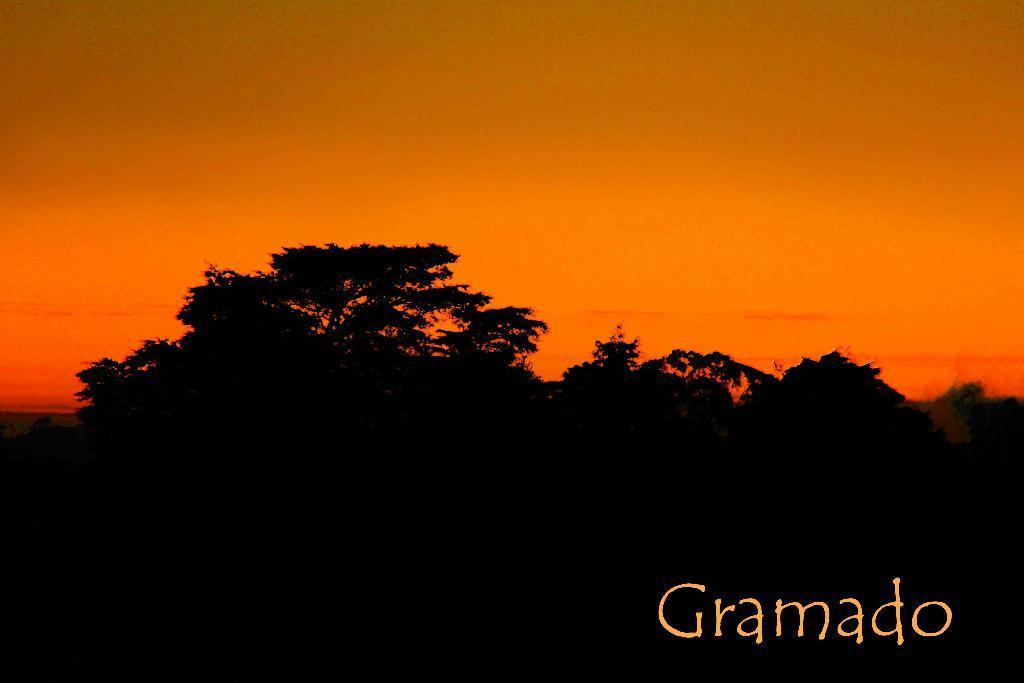Please provide a concise description of this image. This picture consists of dark view at the bottom and I can see trees and text at the bottom , in the middle I can see orange color. 